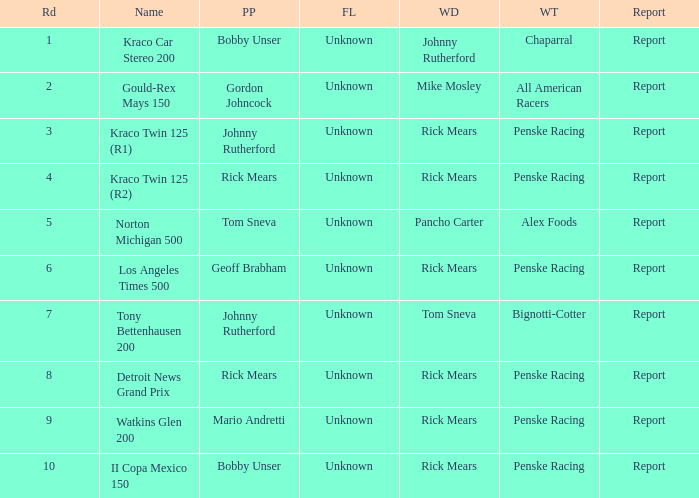The race tony bettenhausen 200 has what smallest rd? 7.0. 